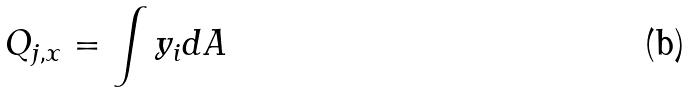Convert formula to latex. <formula><loc_0><loc_0><loc_500><loc_500>Q _ { j , x } = \int y _ { i } d A</formula> 